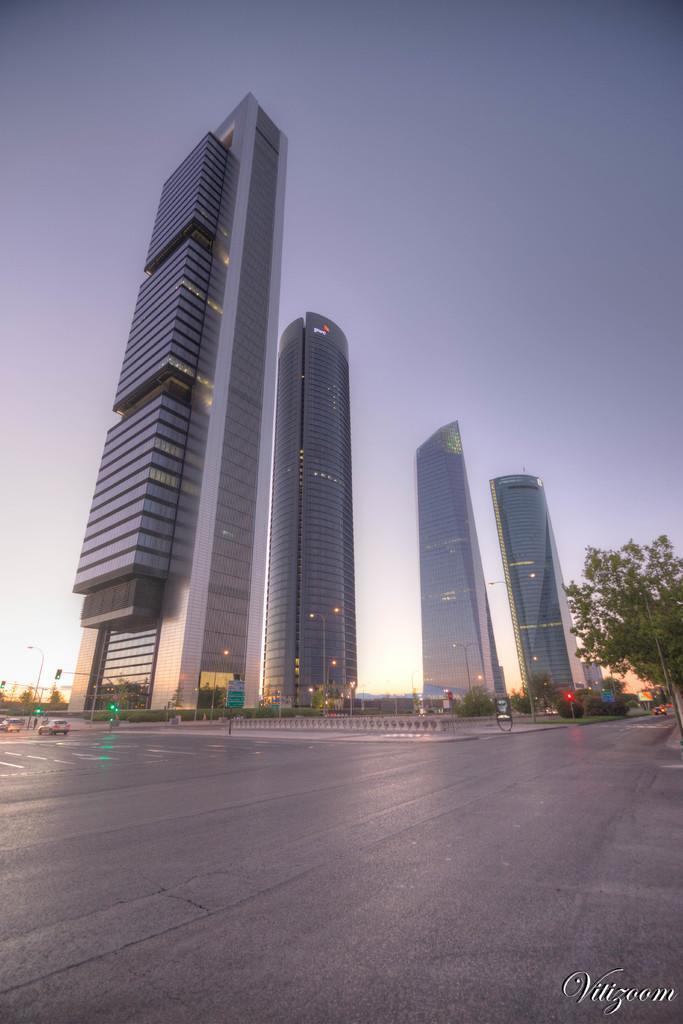Can you describe this image briefly? In this image we can see there is a road. At the center of the image there are buildings. On the right side there is a tree. In the background there is a sky. 